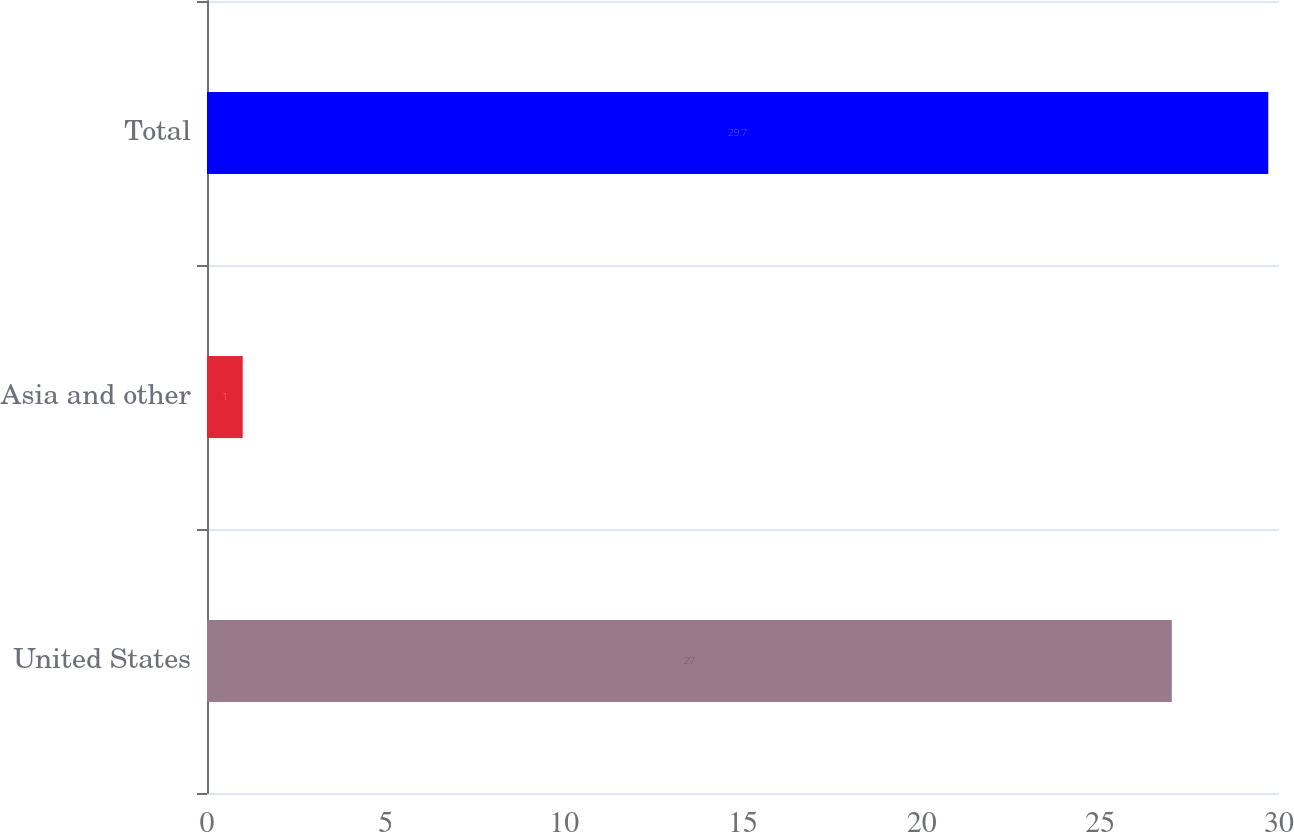Convert chart. <chart><loc_0><loc_0><loc_500><loc_500><bar_chart><fcel>United States<fcel>Asia and other<fcel>Total<nl><fcel>27<fcel>1<fcel>29.7<nl></chart> 